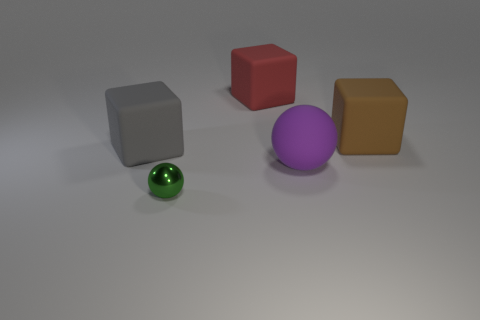Subtract all red rubber cubes. How many cubes are left? 2 Add 2 gray cubes. How many objects exist? 7 Subtract all red blocks. How many blocks are left? 2 Subtract 1 spheres. How many spheres are left? 1 Subtract all blocks. How many objects are left? 2 Add 5 brown matte cubes. How many brown matte cubes exist? 6 Subtract 0 cyan spheres. How many objects are left? 5 Subtract all brown blocks. Subtract all yellow spheres. How many blocks are left? 2 Subtract all big cyan balls. Subtract all tiny metal spheres. How many objects are left? 4 Add 5 small metal spheres. How many small metal spheres are left? 6 